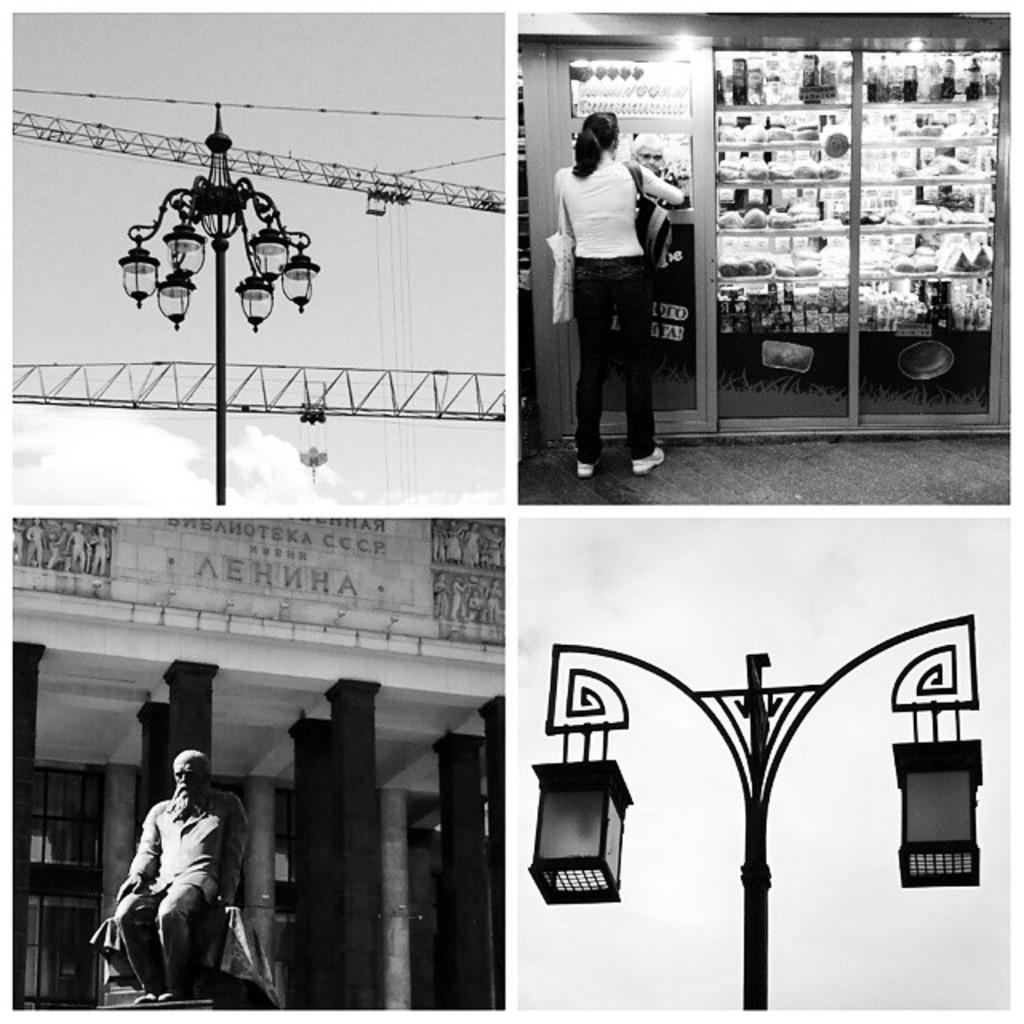Can you describe this image briefly? We can see a collage image of four photos. In the first photo we can see a group of lamps and few objects. In the second photo we can see two persons, a store and many objects placed in it. In the third photo we can see a statue, a building and an advertising board on it. In the fourth photo we can see a street lights and a sky in the image. 